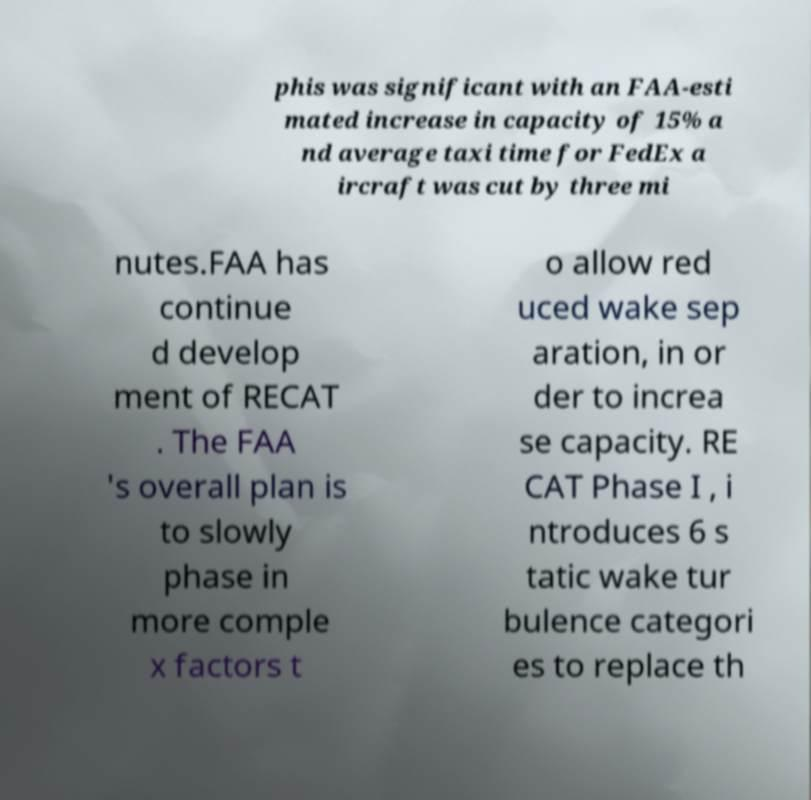For documentation purposes, I need the text within this image transcribed. Could you provide that? phis was significant with an FAA-esti mated increase in capacity of 15% a nd average taxi time for FedEx a ircraft was cut by three mi nutes.FAA has continue d develop ment of RECAT . The FAA 's overall plan is to slowly phase in more comple x factors t o allow red uced wake sep aration, in or der to increa se capacity. RE CAT Phase I , i ntroduces 6 s tatic wake tur bulence categori es to replace th 